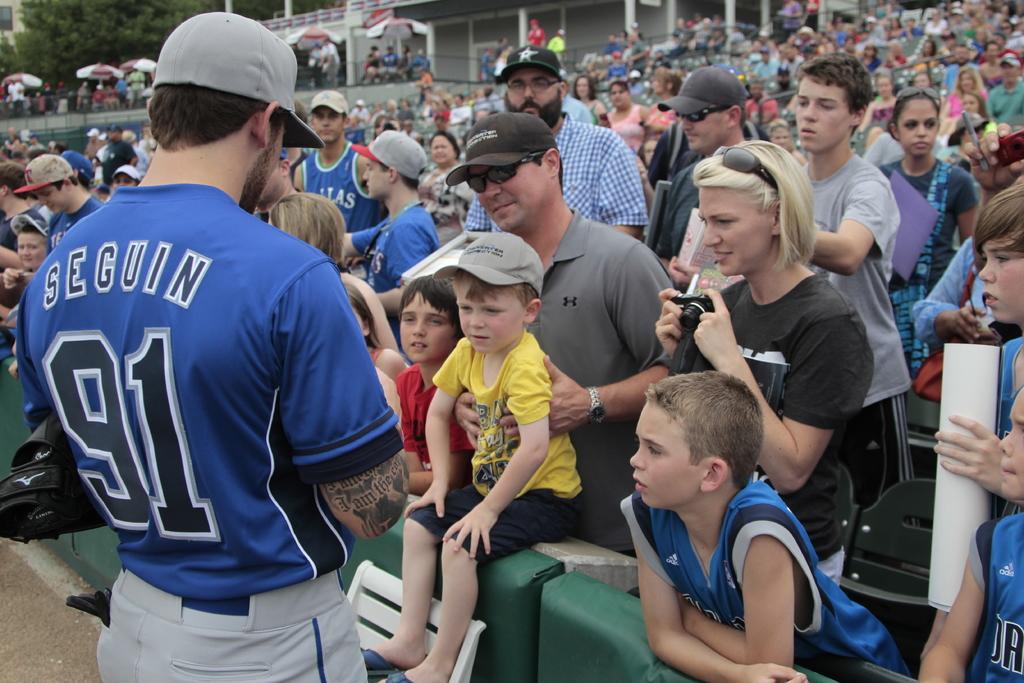What is the last name of the player wearing the jersey number 91?
Offer a terse response. Seguin. What is seguin's number?
Your response must be concise. 91. 